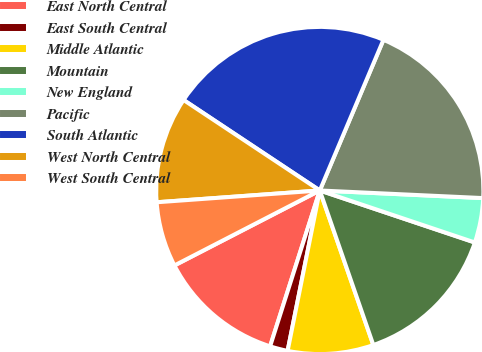<chart> <loc_0><loc_0><loc_500><loc_500><pie_chart><fcel>East North Central<fcel>East South Central<fcel>Middle Atlantic<fcel>Mountain<fcel>New England<fcel>Pacific<fcel>South Atlantic<fcel>West North Central<fcel>West South Central<nl><fcel>12.51%<fcel>1.76%<fcel>8.46%<fcel>14.54%<fcel>4.41%<fcel>19.38%<fcel>22.03%<fcel>10.48%<fcel>6.43%<nl></chart> 